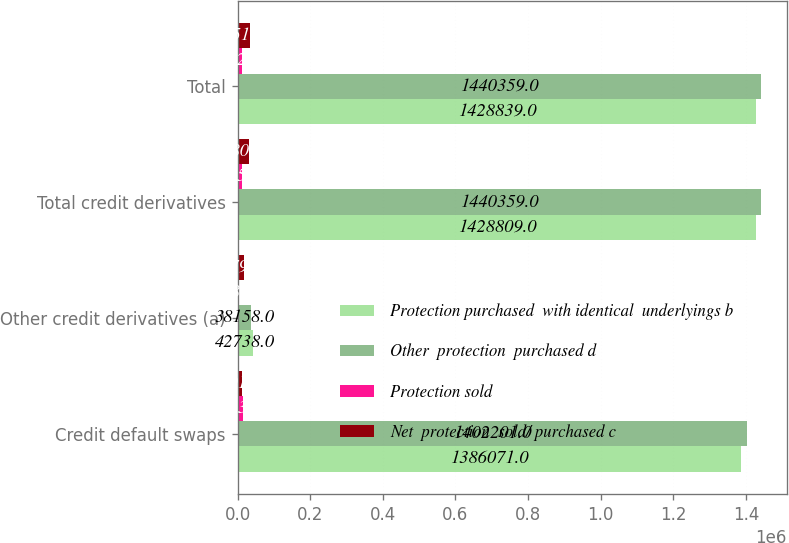Convert chart. <chart><loc_0><loc_0><loc_500><loc_500><stacked_bar_chart><ecel><fcel>Credit default swaps<fcel>Other credit derivatives (a)<fcel>Total credit derivatives<fcel>Total<nl><fcel>Protection purchased  with identical  underlyings b<fcel>1.38607e+06<fcel>42738<fcel>1.42881e+06<fcel>1.42884e+06<nl><fcel>Other  protection  purchased d<fcel>1.4022e+06<fcel>38158<fcel>1.44036e+06<fcel>1.44036e+06<nl><fcel>Protection sold<fcel>16130<fcel>4580<fcel>11550<fcel>11520<nl><fcel>Net  protection  sold/ purchased c<fcel>12011<fcel>18792<fcel>30803<fcel>35518<nl></chart> 